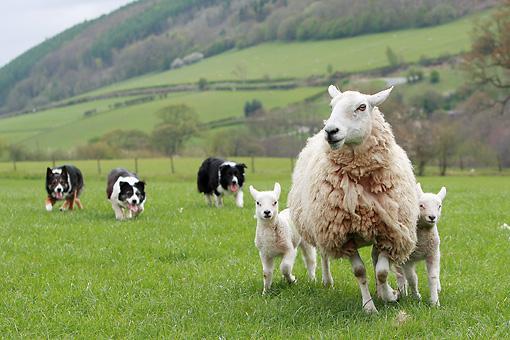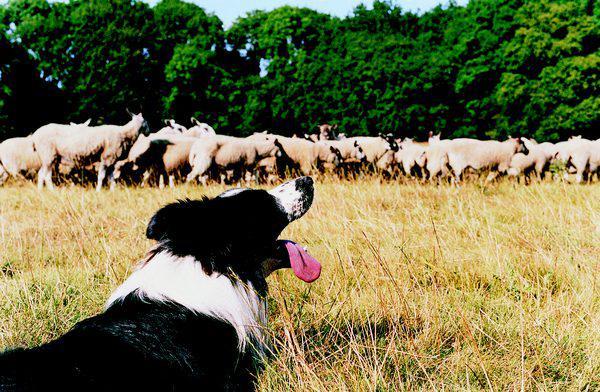The first image is the image on the left, the second image is the image on the right. For the images displayed, is the sentence "One of the images contains exactly three sheep" factually correct? Answer yes or no. Yes. The first image is the image on the left, the second image is the image on the right. Evaluate the accuracy of this statement regarding the images: "An image shows just one herd dog behind and to the left of a group of sheep.". Is it true? Answer yes or no. No. 